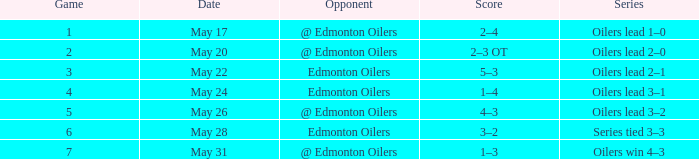Opponent of @ edmonton oilers, and a Game larger than 1, and a Series of oilers lead 3–2 had what score? 4–3. 